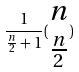<formula> <loc_0><loc_0><loc_500><loc_500>\frac { 1 } { \frac { n } { 2 } + 1 } ( \begin{matrix} n \\ \frac { n } { 2 } \end{matrix} )</formula> 